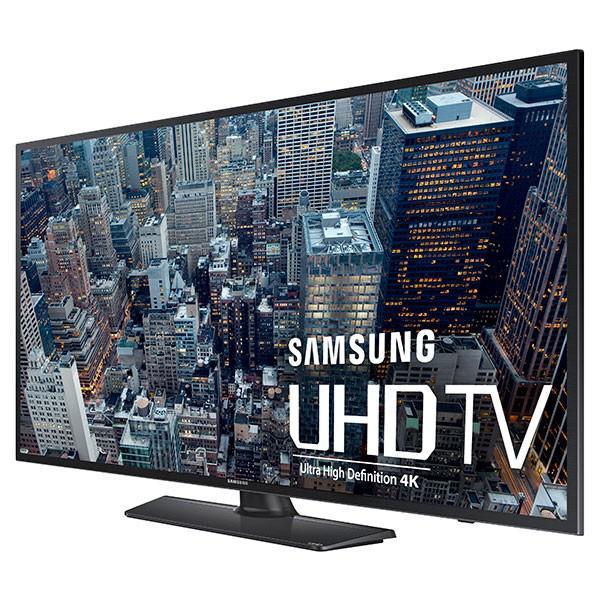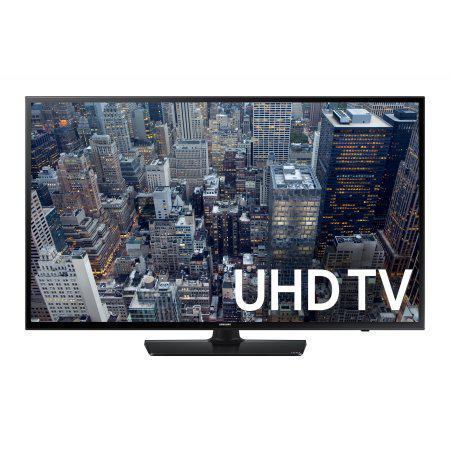The first image is the image on the left, the second image is the image on the right. For the images displayed, is the sentence "Each image is of a single high definition flat screen television set to a standard advertisement screen, with its stand visible below the television." factually correct? Answer yes or no. Yes. The first image is the image on the left, the second image is the image on the right. Given the left and right images, does the statement "Each image shows a single flat screen TV, and at least one image features an aerial city view on the screen." hold true? Answer yes or no. Yes. 